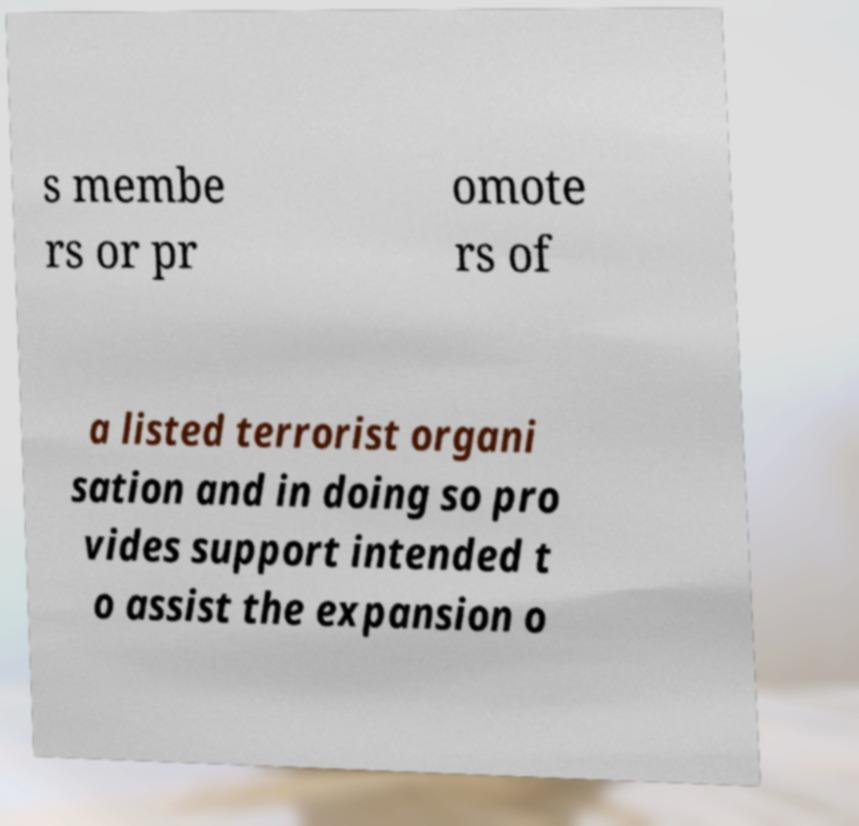Could you extract and type out the text from this image? s membe rs or pr omote rs of a listed terrorist organi sation and in doing so pro vides support intended t o assist the expansion o 